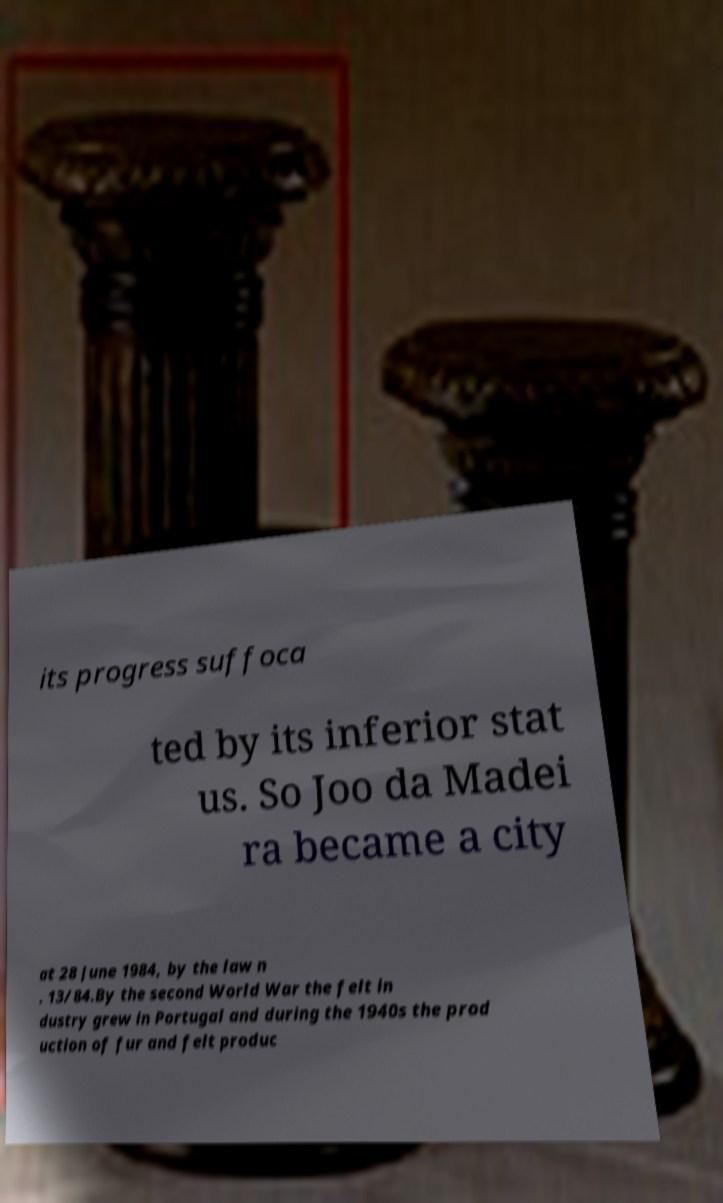Can you accurately transcribe the text from the provided image for me? its progress suffoca ted by its inferior stat us. So Joo da Madei ra became a city at 28 June 1984, by the law n . 13/84.By the second World War the felt in dustry grew in Portugal and during the 1940s the prod uction of fur and felt produc 